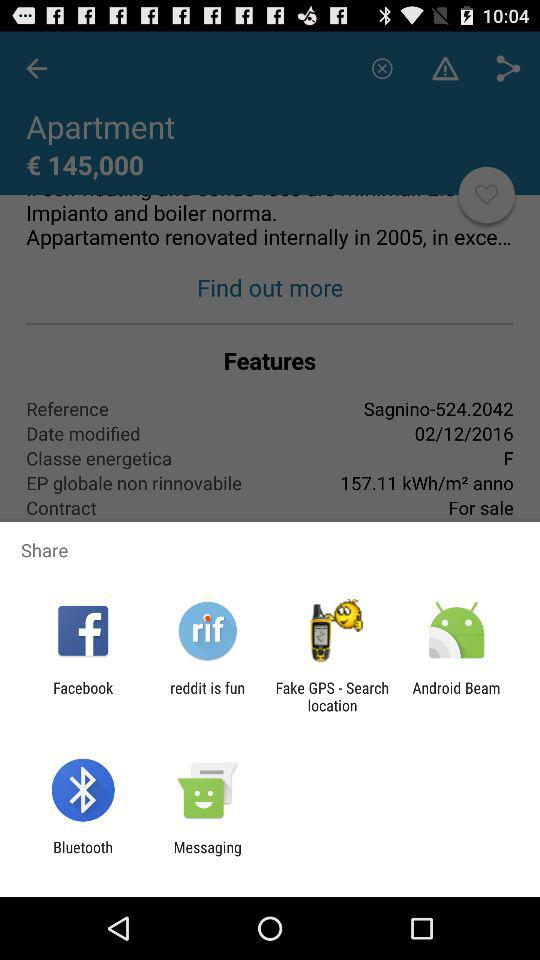What date is given for modification? The given date is 02/12/2016. 